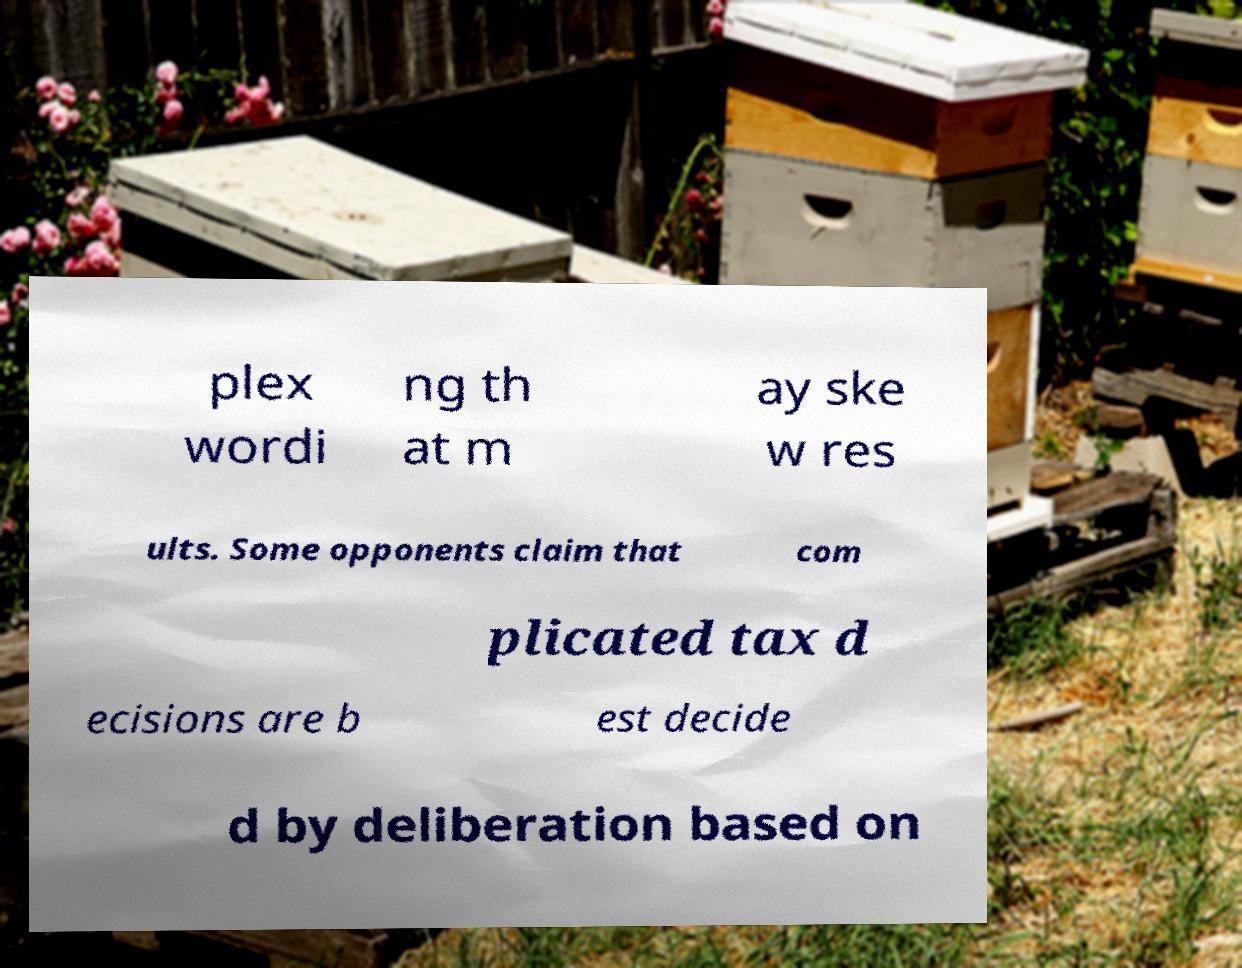I need the written content from this picture converted into text. Can you do that? plex wordi ng th at m ay ske w res ults. Some opponents claim that com plicated tax d ecisions are b est decide d by deliberation based on 